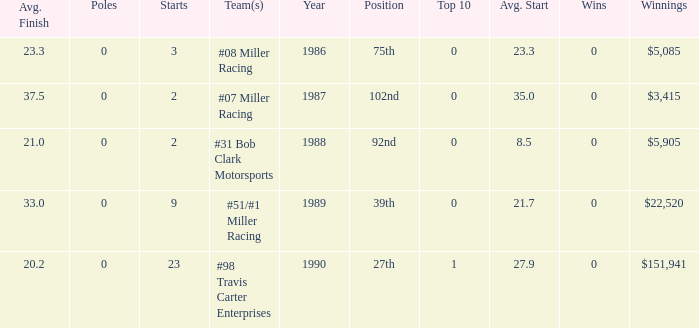What racing team/s had the 92nd position? #31 Bob Clark Motorsports. 